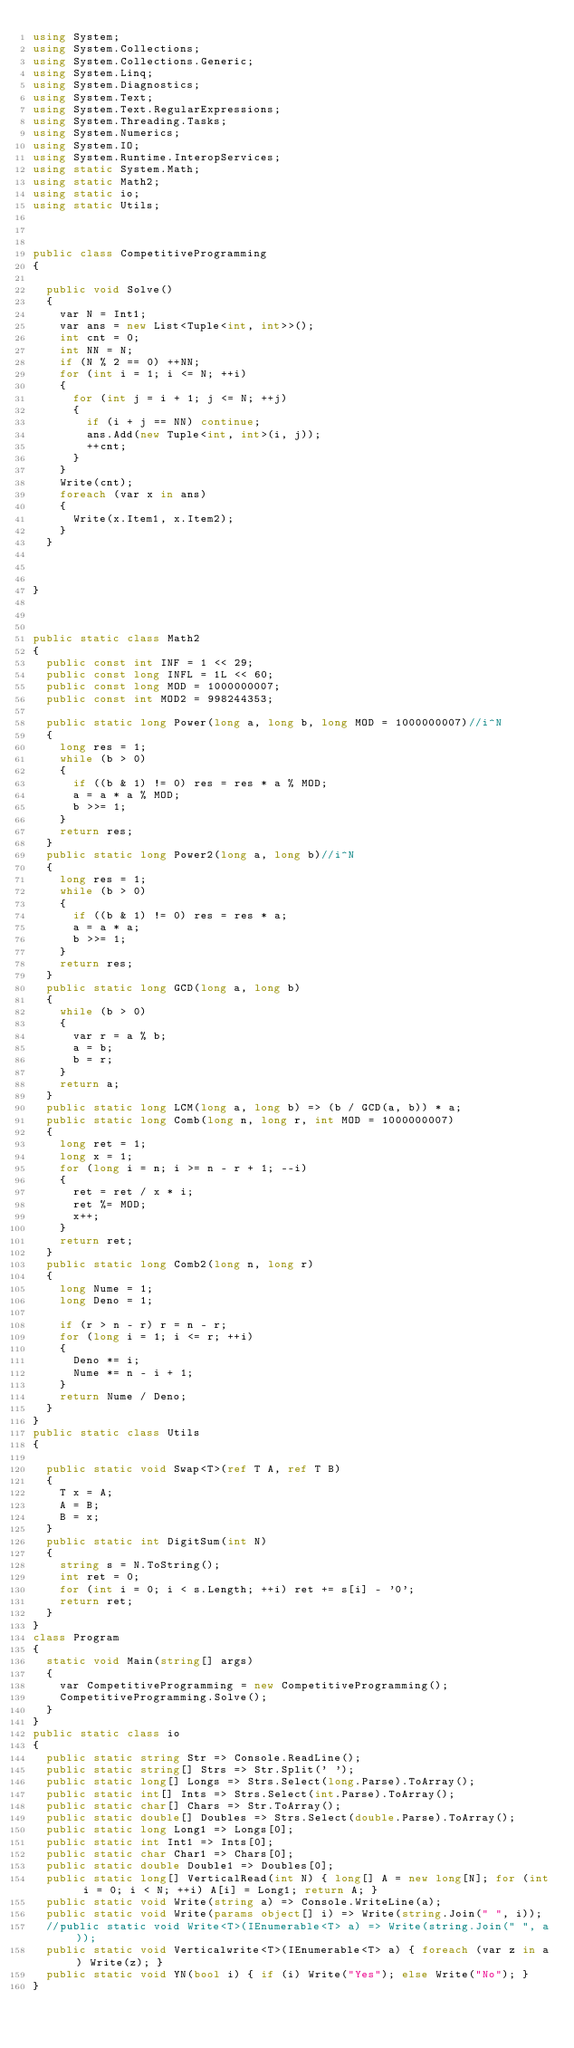Convert code to text. <code><loc_0><loc_0><loc_500><loc_500><_C#_>using System;
using System.Collections;
using System.Collections.Generic;
using System.Linq;
using System.Diagnostics;
using System.Text;
using System.Text.RegularExpressions;
using System.Threading.Tasks;
using System.Numerics;
using System.IO;
using System.Runtime.InteropServices;
using static System.Math;
using static Math2;
using static io;
using static Utils;



public class CompetitiveProgramming
{

  public void Solve()
  {
    var N = Int1;
    var ans = new List<Tuple<int, int>>();
    int cnt = 0;
    int NN = N;
    if (N % 2 == 0) ++NN;
    for (int i = 1; i <= N; ++i)
    {
      for (int j = i + 1; j <= N; ++j)
      {
        if (i + j == NN) continue;
        ans.Add(new Tuple<int, int>(i, j));
        ++cnt;
      }
    }
    Write(cnt);
    foreach (var x in ans)
    {
      Write(x.Item1, x.Item2);
    }
  }



}



public static class Math2
{
  public const int INF = 1 << 29;
  public const long INFL = 1L << 60;
  public const long MOD = 1000000007;
  public const int MOD2 = 998244353;

  public static long Power(long a, long b, long MOD = 1000000007)//i^N
  {
    long res = 1;
    while (b > 0)
    {
      if ((b & 1) != 0) res = res * a % MOD;
      a = a * a % MOD;
      b >>= 1;
    }
    return res;
  }
  public static long Power2(long a, long b)//i^N
  {
    long res = 1;
    while (b > 0)
    {
      if ((b & 1) != 0) res = res * a;
      a = a * a;
      b >>= 1;
    }
    return res;
  }
  public static long GCD(long a, long b)
  {
    while (b > 0)
    {
      var r = a % b;
      a = b;
      b = r;
    }
    return a;
  }
  public static long LCM(long a, long b) => (b / GCD(a, b)) * a;
  public static long Comb(long n, long r, int MOD = 1000000007)
  {
    long ret = 1;
    long x = 1;
    for (long i = n; i >= n - r + 1; --i)
    {
      ret = ret / x * i;
      ret %= MOD;
      x++;
    }
    return ret;
  }
  public static long Comb2(long n, long r)
  {
    long Nume = 1;
    long Deno = 1;

    if (r > n - r) r = n - r;
    for (long i = 1; i <= r; ++i)
    {
      Deno *= i;
      Nume *= n - i + 1;
    }
    return Nume / Deno;
  }
}
public static class Utils
{

  public static void Swap<T>(ref T A, ref T B)
  {
    T x = A;
    A = B;
    B = x;
  }
  public static int DigitSum(int N)
  {
    string s = N.ToString();
    int ret = 0;
    for (int i = 0; i < s.Length; ++i) ret += s[i] - '0';
    return ret;
  }
}
class Program
{
  static void Main(string[] args)
  {
    var CompetitiveProgramming = new CompetitiveProgramming();
    CompetitiveProgramming.Solve();
  }
}
public static class io
{
  public static string Str => Console.ReadLine();
  public static string[] Strs => Str.Split(' ');
  public static long[] Longs => Strs.Select(long.Parse).ToArray();
  public static int[] Ints => Strs.Select(int.Parse).ToArray();
  public static char[] Chars => Str.ToArray();
  public static double[] Doubles => Strs.Select(double.Parse).ToArray();
  public static long Long1 => Longs[0];
  public static int Int1 => Ints[0];
  public static char Char1 => Chars[0];
  public static double Double1 => Doubles[0];
  public static long[] VerticalRead(int N) { long[] A = new long[N]; for (int i = 0; i < N; ++i) A[i] = Long1; return A; }
  public static void Write(string a) => Console.WriteLine(a);
  public static void Write(params object[] i) => Write(string.Join(" ", i));
  //public static void Write<T>(IEnumerable<T> a) => Write(string.Join(" ", a));
  public static void Verticalwrite<T>(IEnumerable<T> a) { foreach (var z in a) Write(z); }
  public static void YN(bool i) { if (i) Write("Yes"); else Write("No"); }
}
</code> 